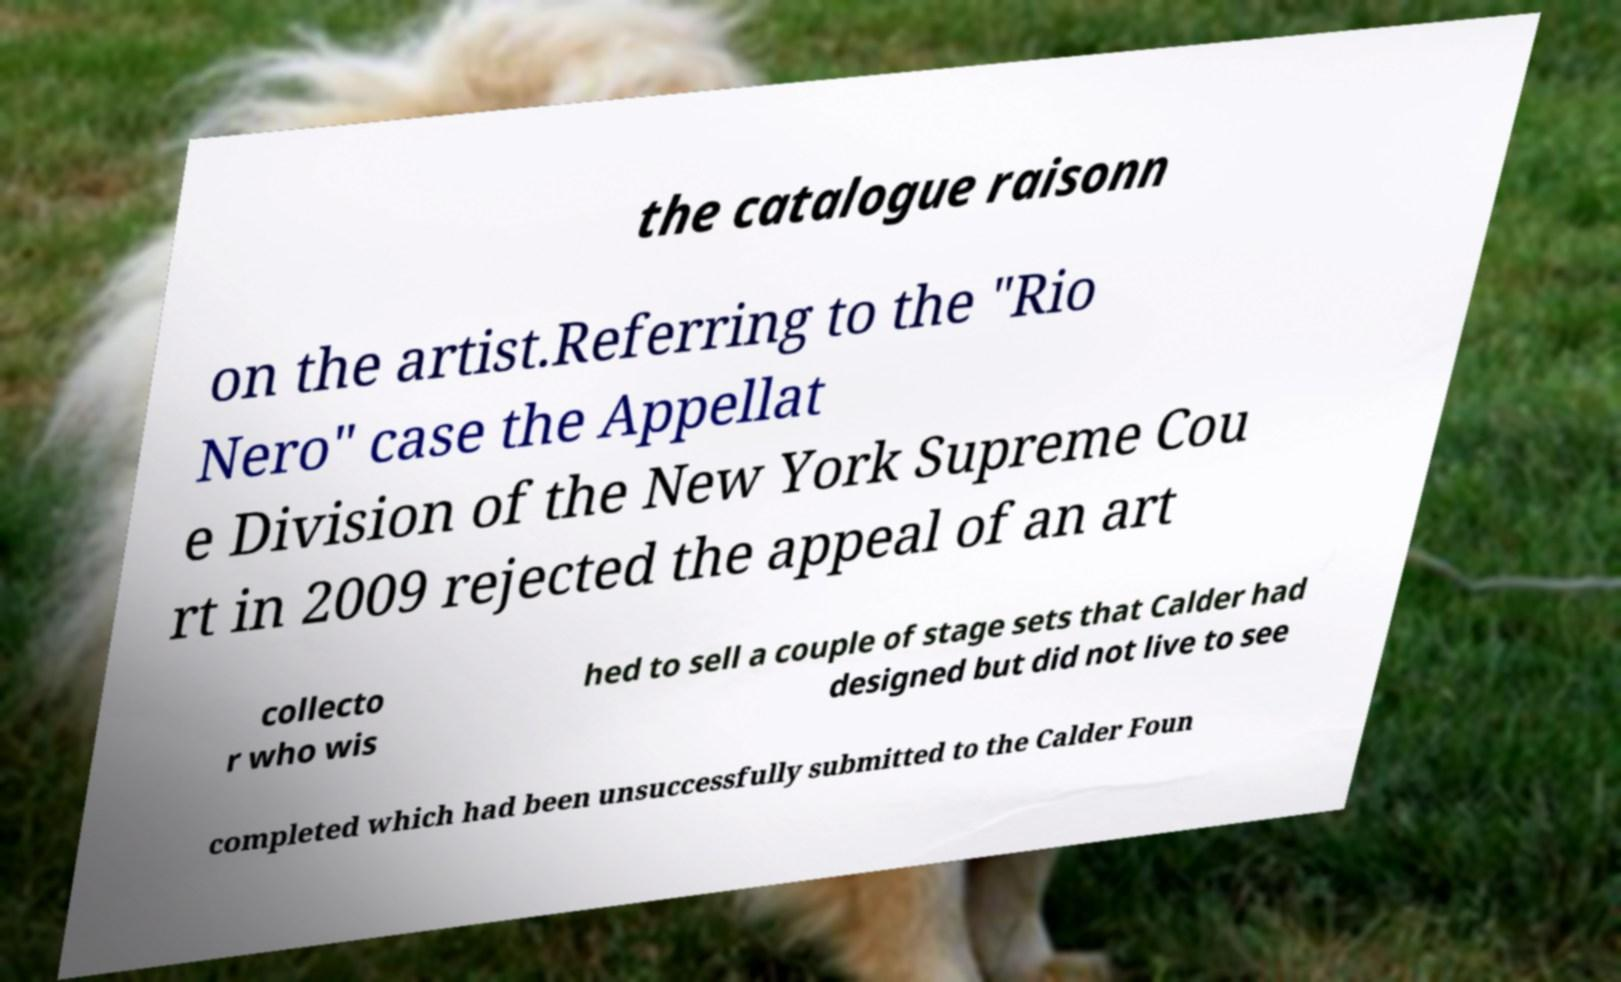Can you read and provide the text displayed in the image?This photo seems to have some interesting text. Can you extract and type it out for me? the catalogue raisonn on the artist.Referring to the "Rio Nero" case the Appellat e Division of the New York Supreme Cou rt in 2009 rejected the appeal of an art collecto r who wis hed to sell a couple of stage sets that Calder had designed but did not live to see completed which had been unsuccessfully submitted to the Calder Foun 